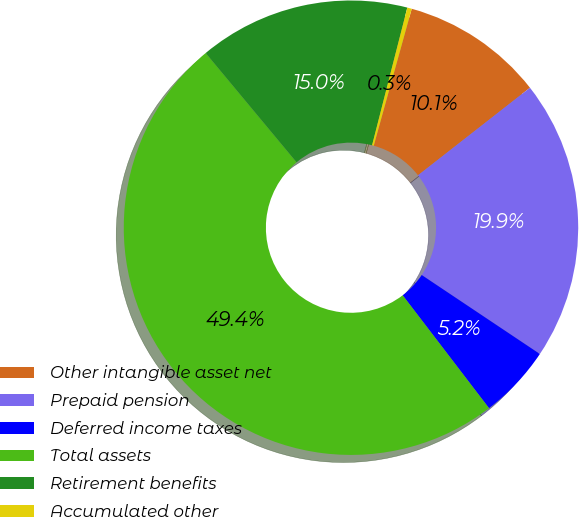<chart> <loc_0><loc_0><loc_500><loc_500><pie_chart><fcel>Other intangible asset net<fcel>Prepaid pension<fcel>Deferred income taxes<fcel>Total assets<fcel>Retirement benefits<fcel>Accumulated other<nl><fcel>10.13%<fcel>19.94%<fcel>5.23%<fcel>49.35%<fcel>15.03%<fcel>0.32%<nl></chart> 